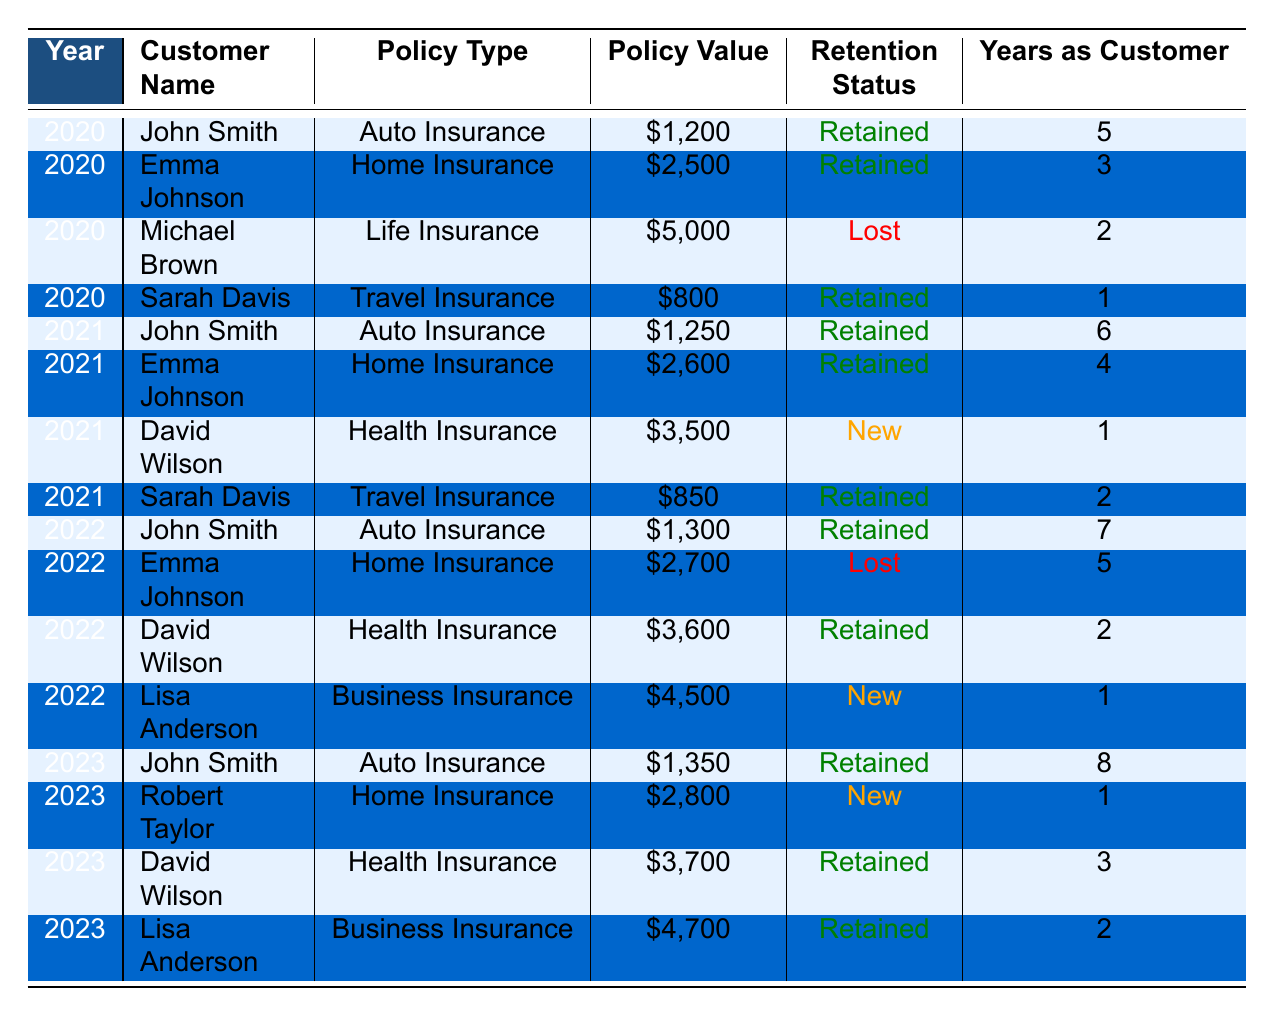What is the policy value of Sarah Davis's Travel Insurance in 2022? In 2022, the table shows that Sarah Davis had a policy value of $850 for Travel Insurance.
Answer: $850 How many years has John Smith been a customer by 2023? According to the table, John Smith has been a customer for 8 years by 2023.
Answer: 8 What was the retention status of Emma Johnson's Home Insurance policy in 2022? In 2022, the table indicates that Emma Johnson's Home Insurance policy was marked as "Lost".
Answer: Lost Calculate the average policy value for retained customers in 2021. For retained customers in 2021, we have John Smith ($1,250), Emma Johnson ($2,600), and Sarah Davis ($850). The sum of these values is $1,250 + $2,600 + $850 = $4,700. Since there are 3 retained customers, the average policy value is $4,700 / 3 = $1,566.67.
Answer: $1,566.67 Is Lisa Anderson's Business Insurance policy retained in 2023? The table shows that Lisa Anderson's Business Insurance policy in 2023 is indicated as "Retained".
Answer: Yes What is the total policy value for all retained policies in 2023? The retained policies in 2023 are John Smith ($1,350), David Wilson ($3,700), and Lisa Anderson ($4,700). Adding these up gives $1,350 + $3,700 + $4,700 = $9,750.
Answer: $9,750 In which year did Emma Johnson lose her Home Insurance policy? The table indicates that Emma Johnson lost her Home Insurance policy in 2022.
Answer: 2022 How many new customers were there in 2021 and what was their total policy value? The table shows that David Wilson was a new customer in 2021 with a policy value of $3,500. Therefore, there was 1 new customer with a total policy value of $3,500.
Answer: 1 new customer, total $3,500 Which customer had the highest policy value in 2020 and what was that value? In 2020, Michael Brown had the highest policy value of $5,000 for Life Insurance, whereas other retained customers had lower values.
Answer: $5,000 What is the change in policy value for John Smith from 2020 to 2023? In 2020, John Smith's policy value was $1,200, which increased to $1,350 in 2023. Thus, the change is $1,350 - $1,200 = $150.
Answer: $150 